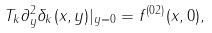Convert formula to latex. <formula><loc_0><loc_0><loc_500><loc_500>T _ { k } \partial _ { y } ^ { 2 } \delta _ { k } ( x , y ) | _ { y = 0 } = f ^ { ( 0 2 ) } ( x , 0 ) ,</formula> 